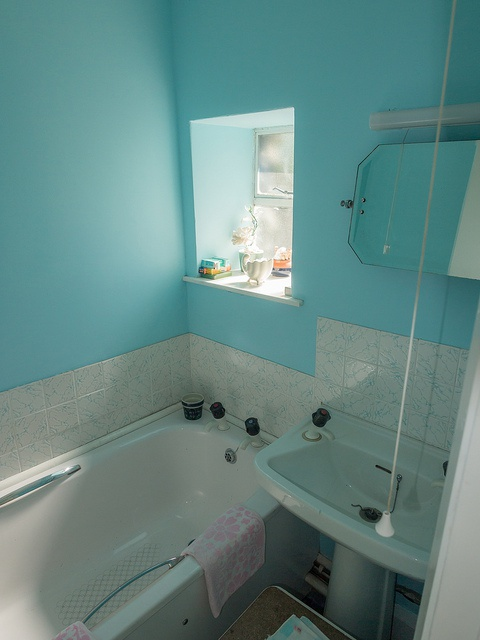Describe the objects in this image and their specific colors. I can see sink in teal and black tones, vase in teal, ivory, beige, darkgray, and lightgray tones, and cup in teal, black, gray, and darkgreen tones in this image. 